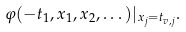<formula> <loc_0><loc_0><loc_500><loc_500>\varphi ( - t _ { 1 } , x _ { 1 } , x _ { 2 } , \dots ) | _ { x _ { j } = t _ { v , j } } .</formula> 